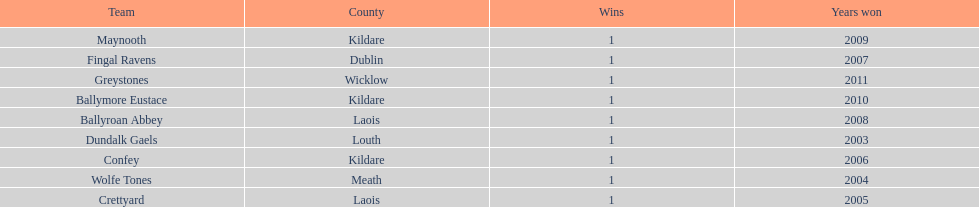How many wins does greystones have? 1. 